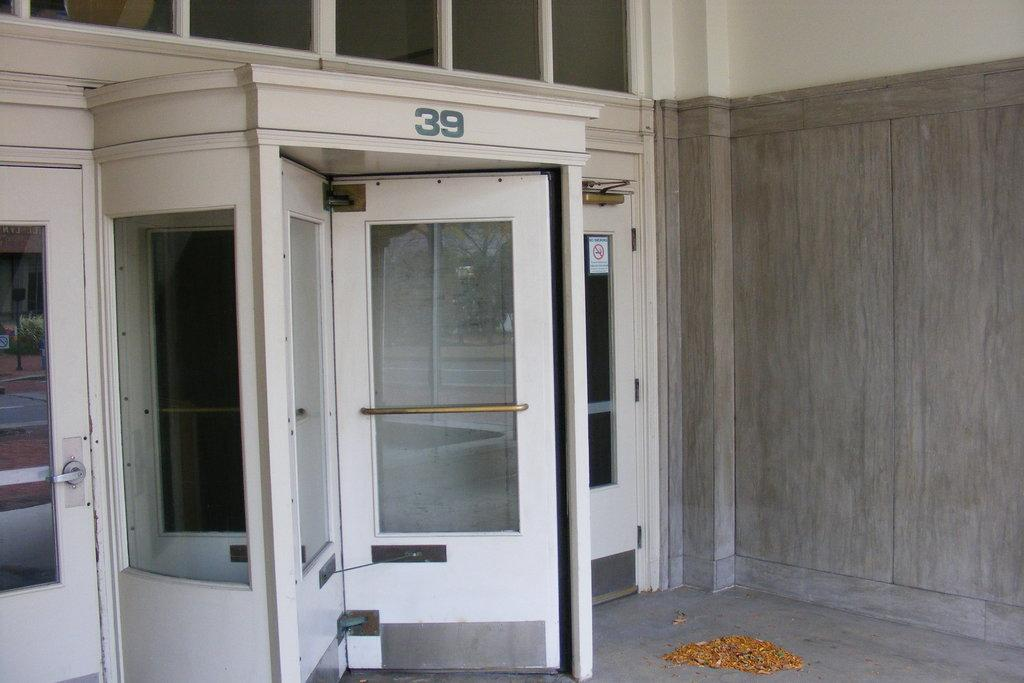<image>
Write a terse but informative summary of the picture. The carousel entrance to a building has the number 39 displayed above it. 